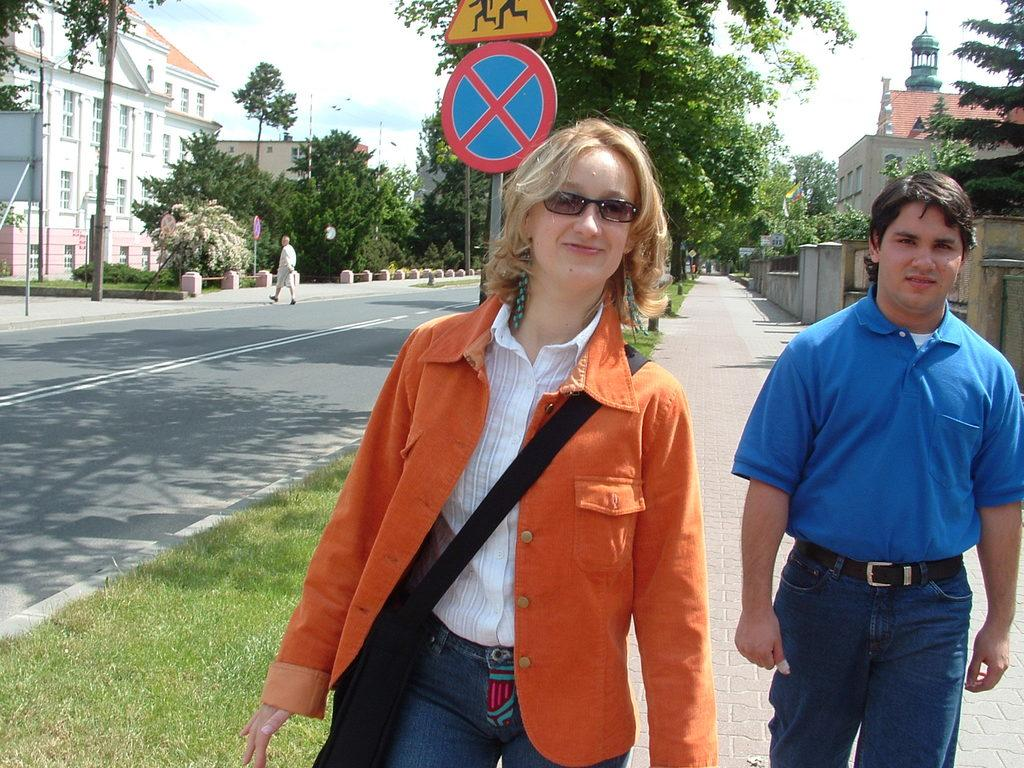What type of structures can be seen in the image? There are buildings in the image. What feature is visible on the buildings? There are windows visible in the image. What type of vegetation is present in the image? There are trees in the image. What are the vertical structures in the image? There are poles in the image. What type of information is displayed in the image? There are signboards in the image. Who or what is present in the image? There are people in the image. What part of the natural environment is visible in the image? The sky is visible in the image. Can you tell me how many bees are sitting on the signboards in the image? There are no bees present in the image; it features buildings, windows, trees, poles, signboards, and people. What type of yard is visible in the image? There is no yard visible in the image. 